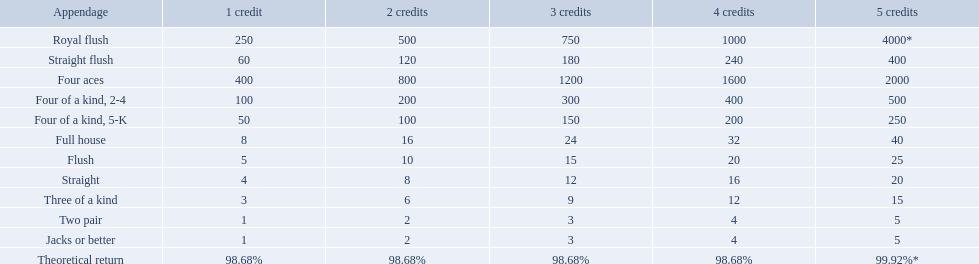Which hand is the third best hand in the card game super aces? Four aces. Which hand is the second best hand? Straight flush. Which hand had is the best hand? Royal flush. What is the higher amount of points for one credit you can get from the best four of a kind 100. What type is it? Four of a kind, 2-4. Parse the full table. {'header': ['Appendage', '1 credit', '2 credits', '3 credits', '4 credits', '5 credits'], 'rows': [['Royal flush', '250', '500', '750', '1000', '4000*'], ['Straight flush', '60', '120', '180', '240', '400'], ['Four aces', '400', '800', '1200', '1600', '2000'], ['Four of a kind, 2-4', '100', '200', '300', '400', '500'], ['Four of a kind, 5-K', '50', '100', '150', '200', '250'], ['Full house', '8', '16', '24', '32', '40'], ['Flush', '5', '10', '15', '20', '25'], ['Straight', '4', '8', '12', '16', '20'], ['Three of a kind', '3', '6', '9', '12', '15'], ['Two pair', '1', '2', '3', '4', '5'], ['Jacks or better', '1', '2', '3', '4', '5'], ['Theoretical return', '98.68%', '98.68%', '98.68%', '98.68%', '99.92%*']]} Which hand is lower than straight flush? Four aces. Which hand is lower than four aces? Four of a kind, 2-4. Which hand is higher out of straight and flush? Flush. 